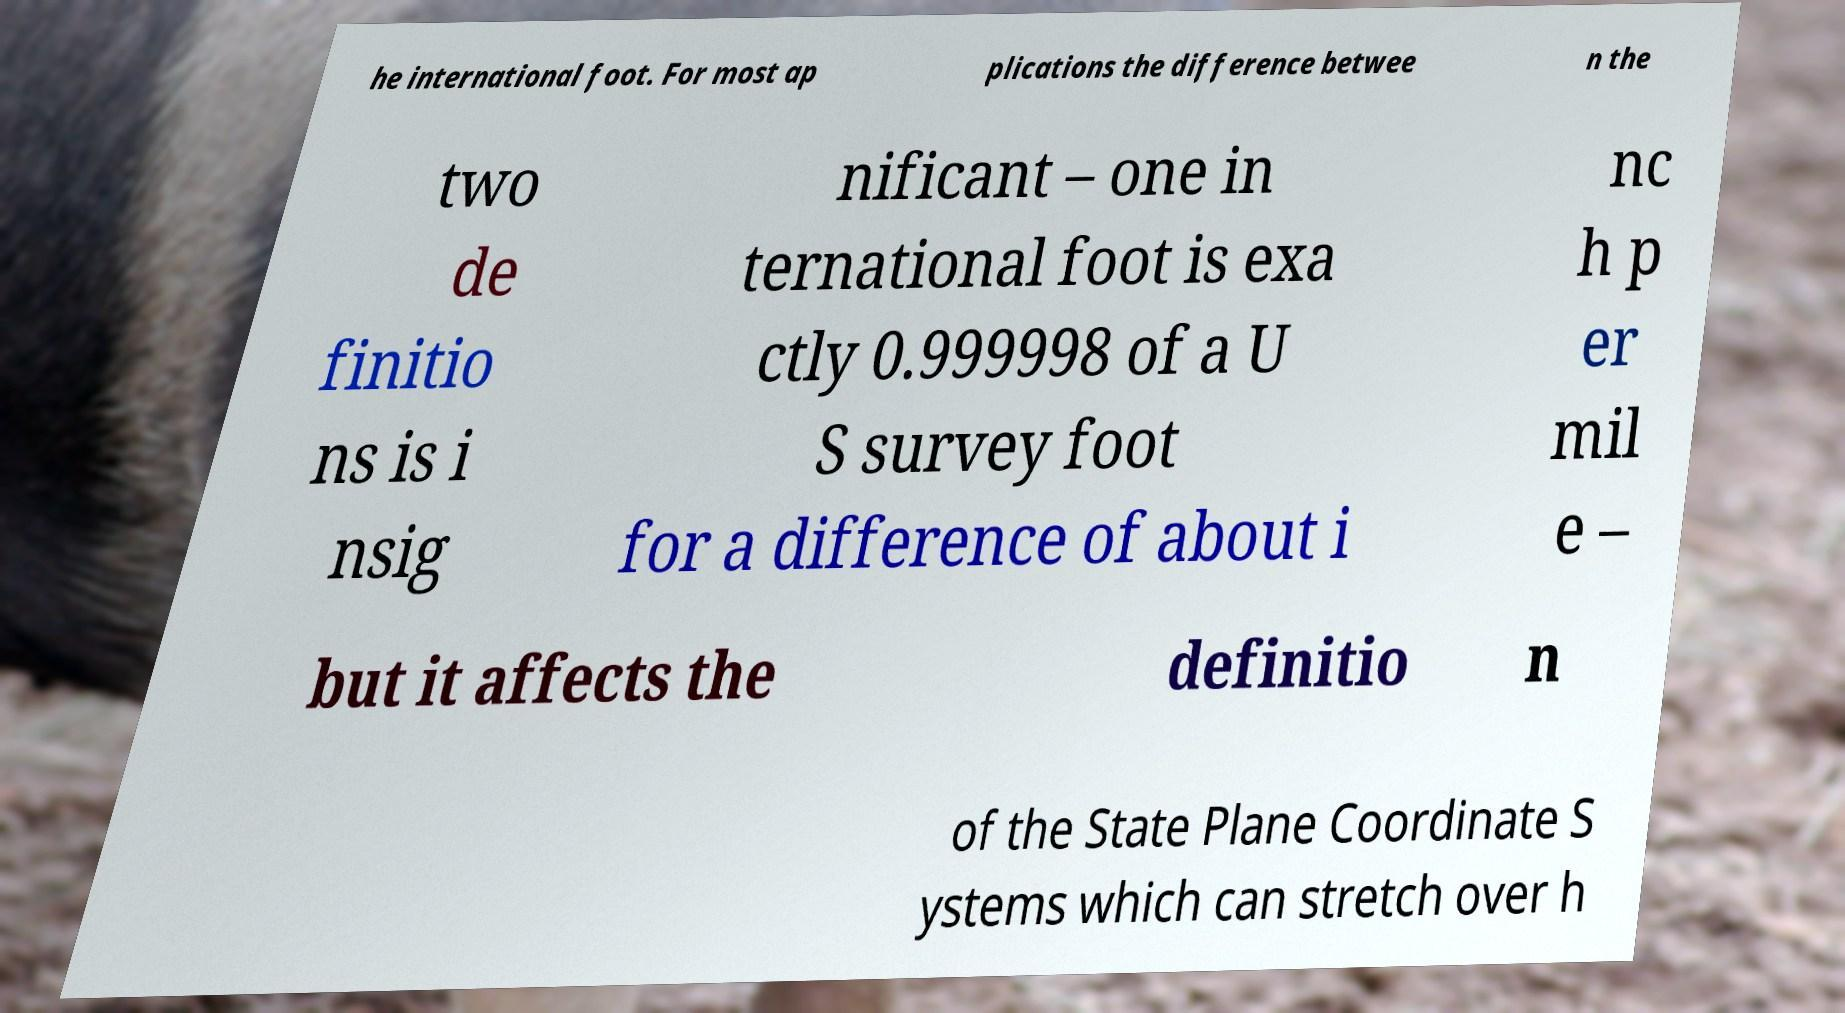Please identify and transcribe the text found in this image. he international foot. For most ap plications the difference betwee n the two de finitio ns is i nsig nificant – one in ternational foot is exa ctly 0.999998 of a U S survey foot for a difference of about i nc h p er mil e – but it affects the definitio n of the State Plane Coordinate S ystems which can stretch over h 